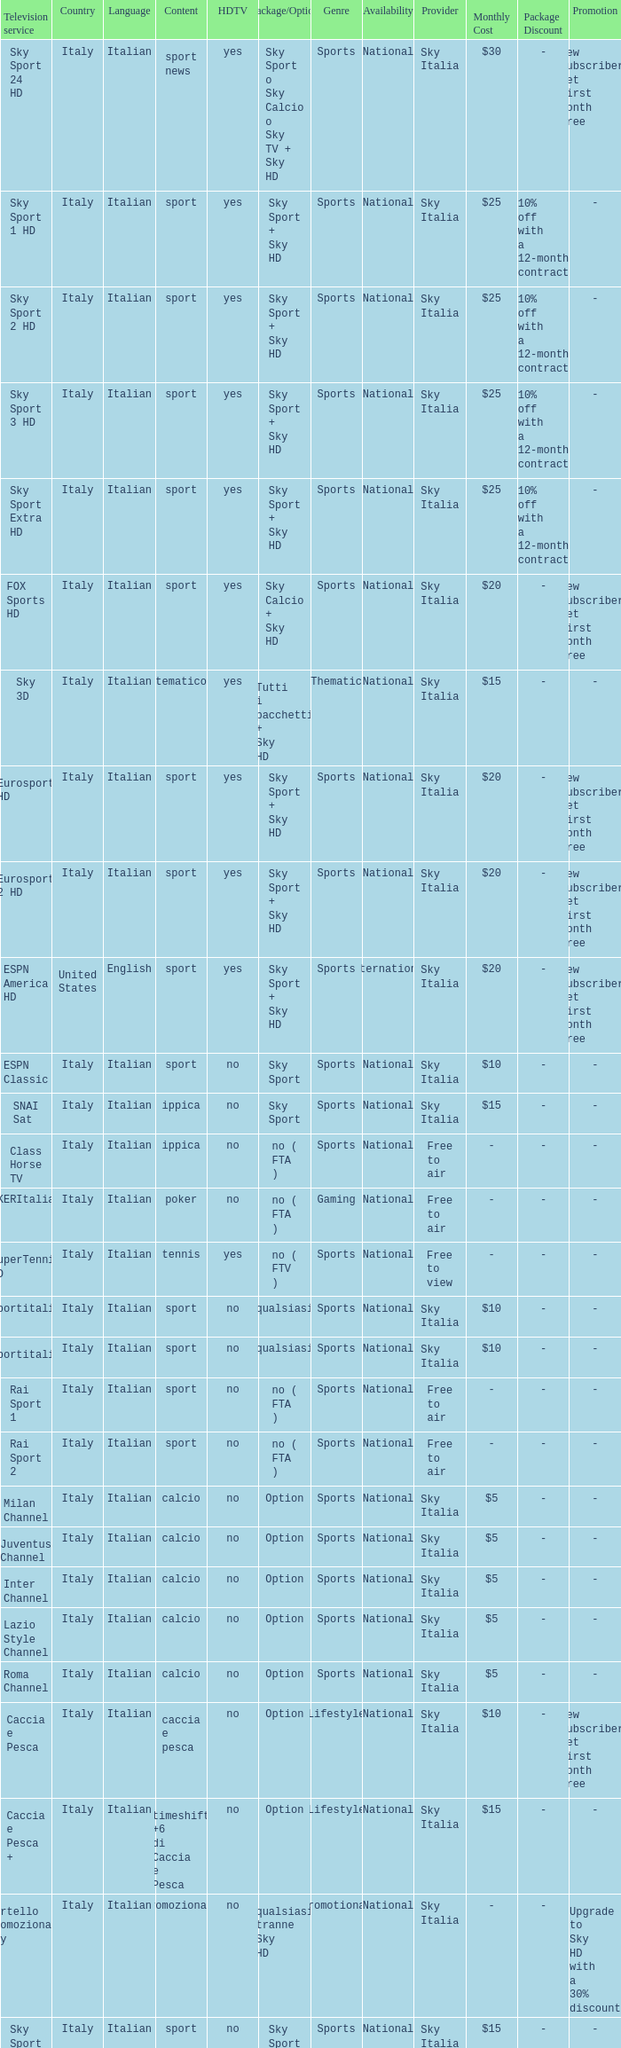What is Package/Option, when Content is Poker? No ( fta ). 